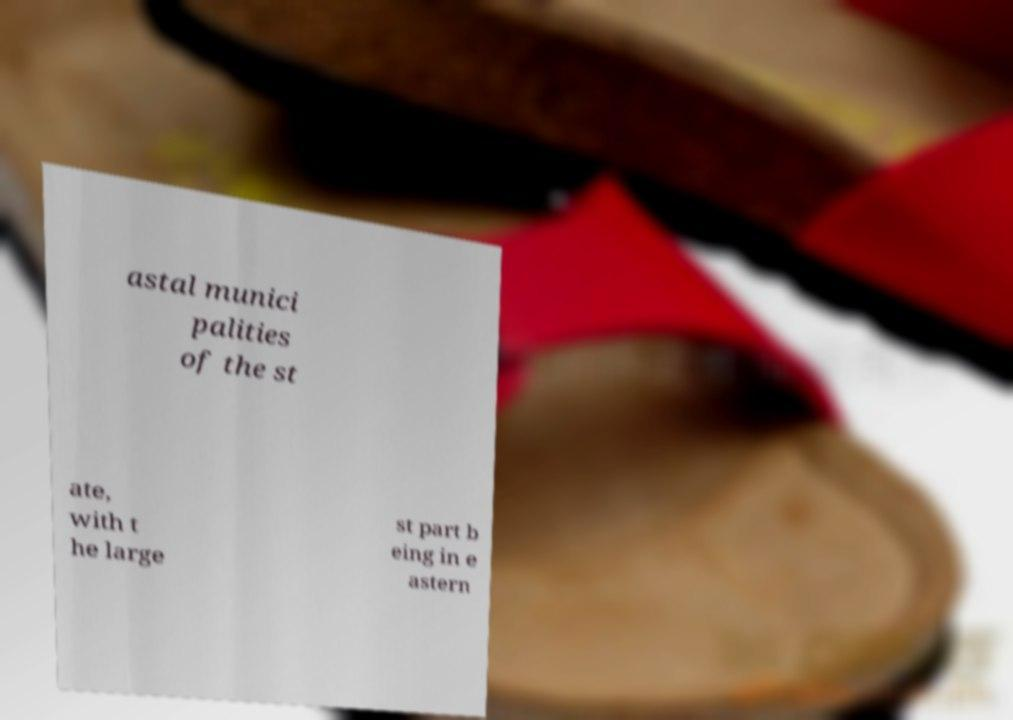Can you accurately transcribe the text from the provided image for me? astal munici palities of the st ate, with t he large st part b eing in e astern 